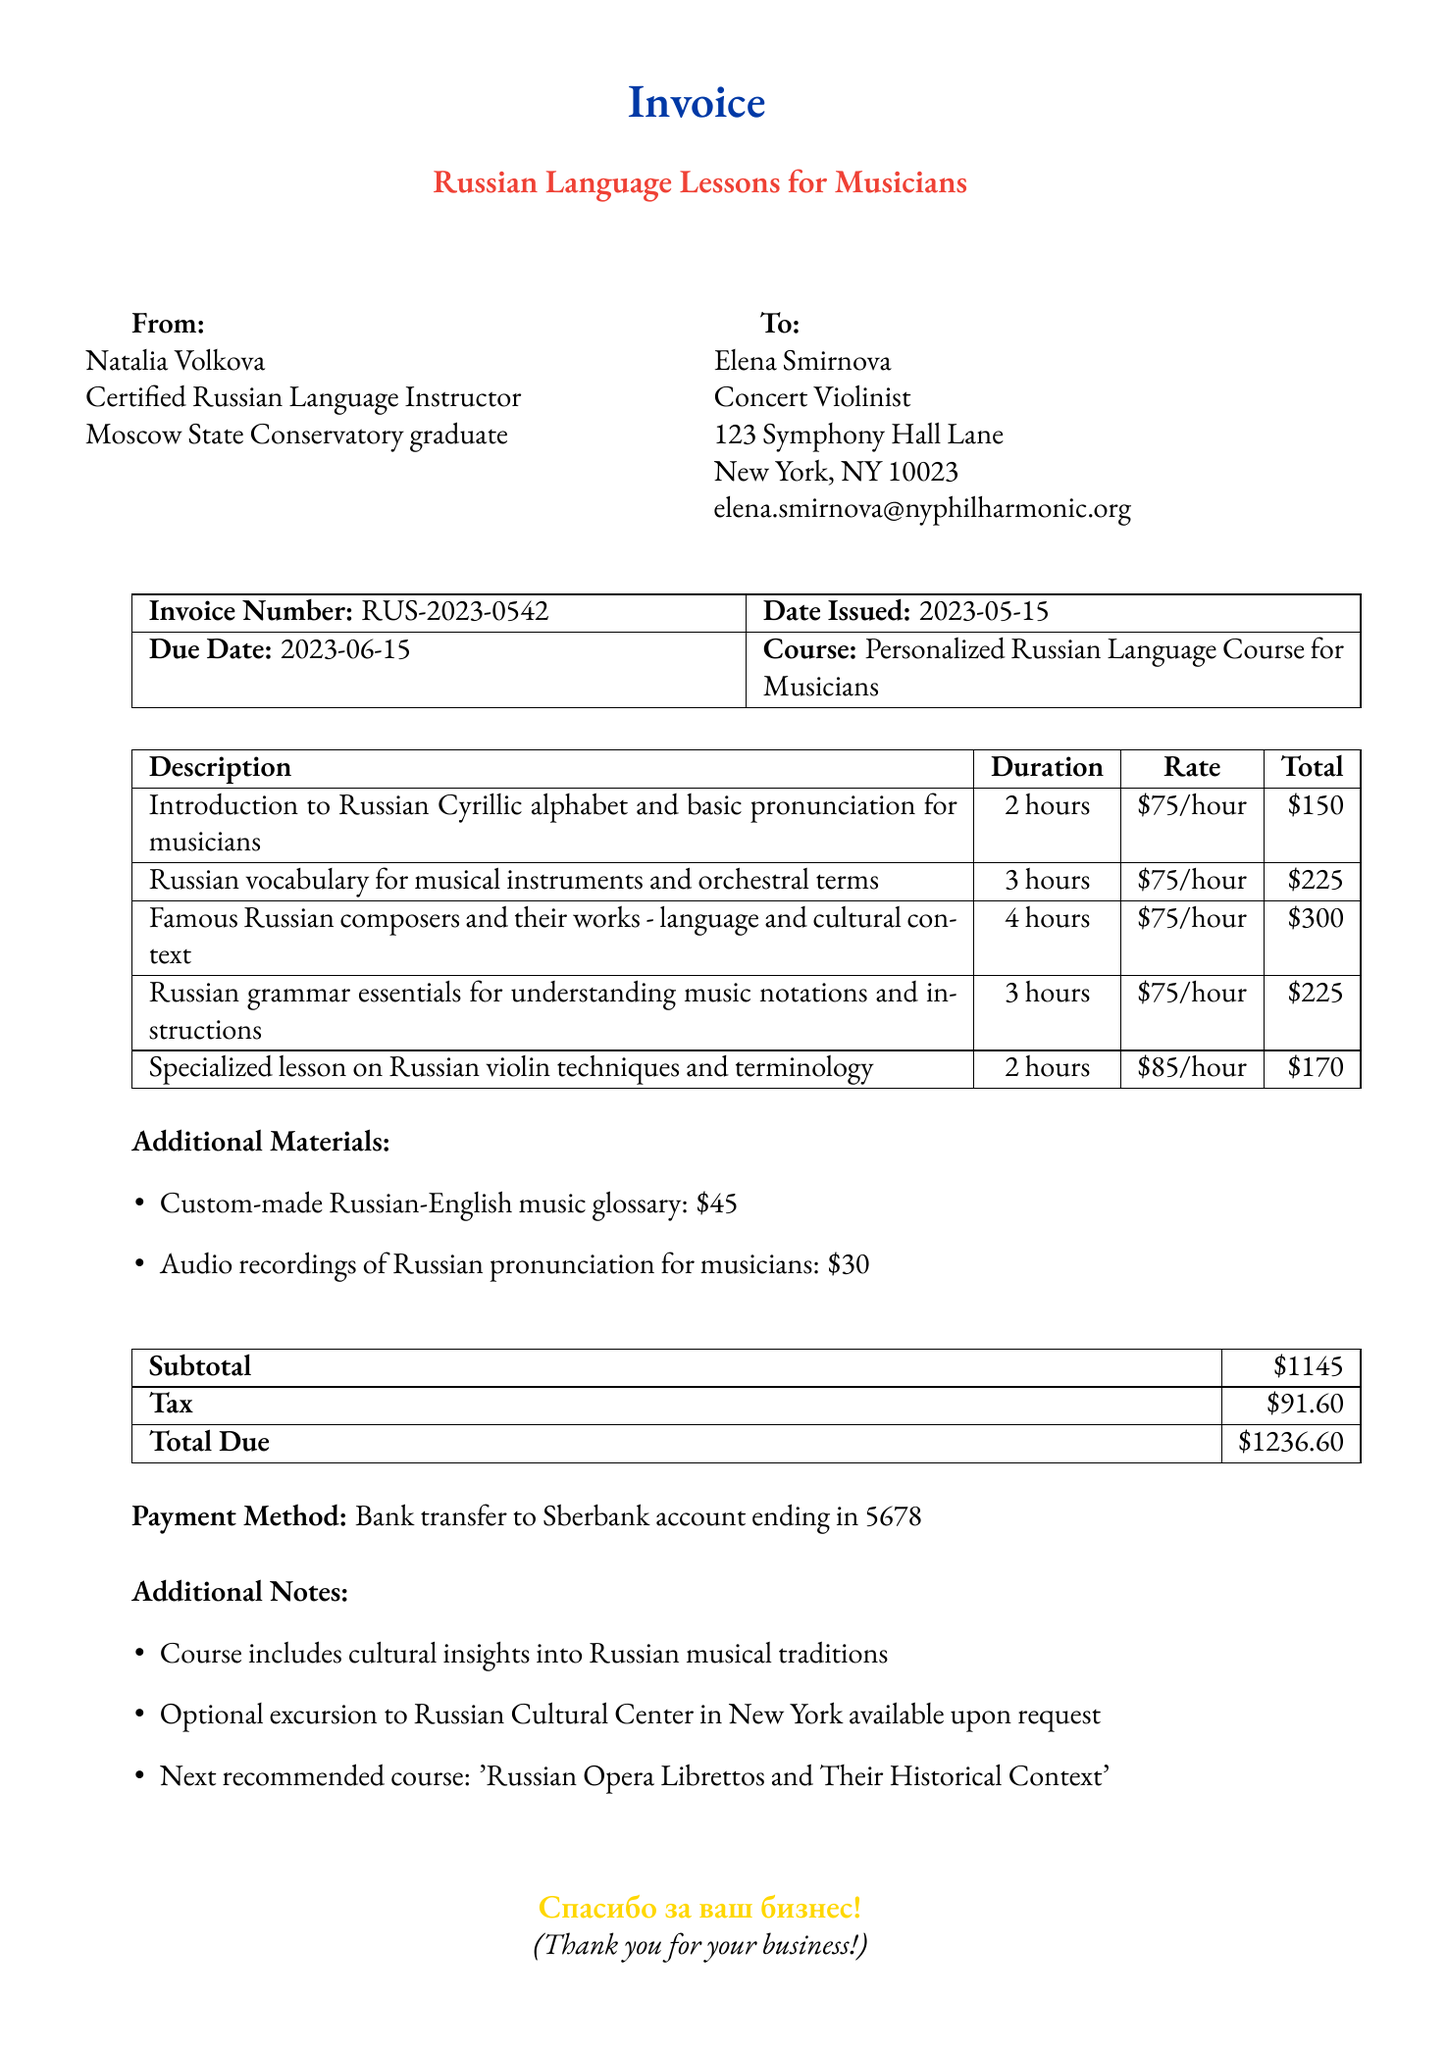What is the invoice number? The invoice number is clearly stated in the document as RUS-2023-0542.
Answer: RUS-2023-0542 Who is the teacher for the language lessons? The document specifies Natalia Volkova as the teacher providing the lessons.
Answer: Natalia Volkova What is the total amount due? The total amount due is clearly labeled in the payment details section as $1236.60.
Answer: $1236.60 How many hours is the lesson on Russian vocabulary for musical instruments? The document lists the duration of this specific lesson as 3 hours.
Answer: 3 hours What payment method is specified in the invoice? The document contains a section detailing the payment method, which is a bank transfer to Sberbank account ending in 5678.
Answer: Bank transfer to Sberbank account ending in 5678 What is the subtotal for the services provided? The subtotal is provided in the payment details section of the invoice as $1145.
Answer: $1145 How many additional materials are listed in the invoice? The document outlines two additional materials available for purchase.
Answer: Two What is the next recommended course mentioned in the notes? The document suggests the next recommended course is 'Russian Opera Librettos and Their Historical Context.'
Answer: Russian Opera Librettos and Their Historical Context What is the focus of the personalized course? The course description at the top of the invoice states it is focused on Russian language for musicians.
Answer: Russian Language Course for Musicians 